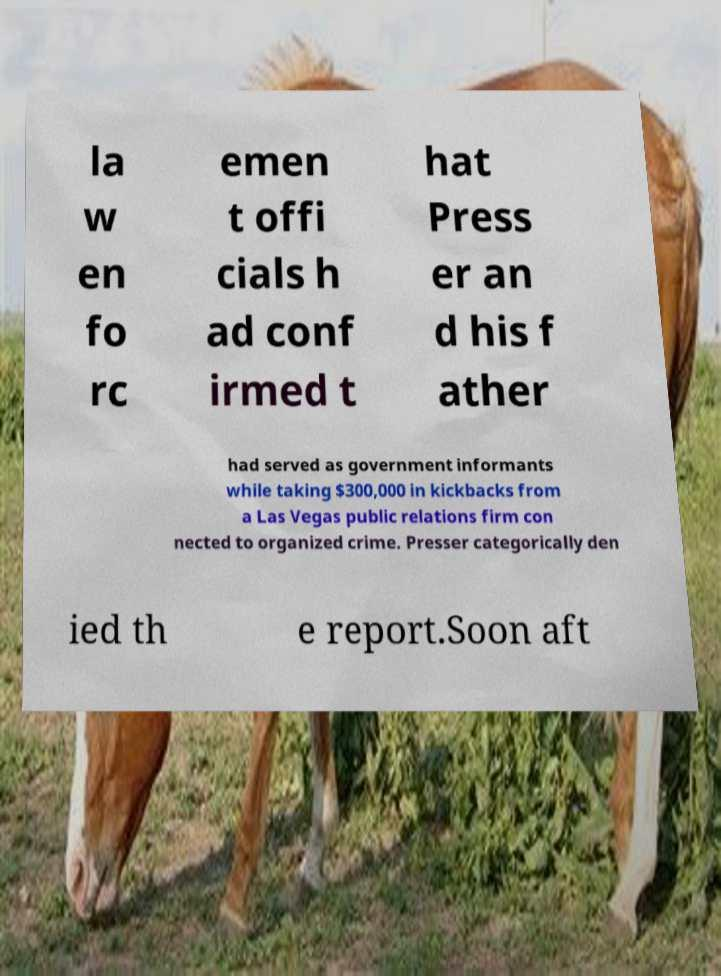Could you assist in decoding the text presented in this image and type it out clearly? la w en fo rc emen t offi cials h ad conf irmed t hat Press er an d his f ather had served as government informants while taking $300,000 in kickbacks from a Las Vegas public relations firm con nected to organized crime. Presser categorically den ied th e report.Soon aft 